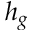Convert formula to latex. <formula><loc_0><loc_0><loc_500><loc_500>h _ { g }</formula> 